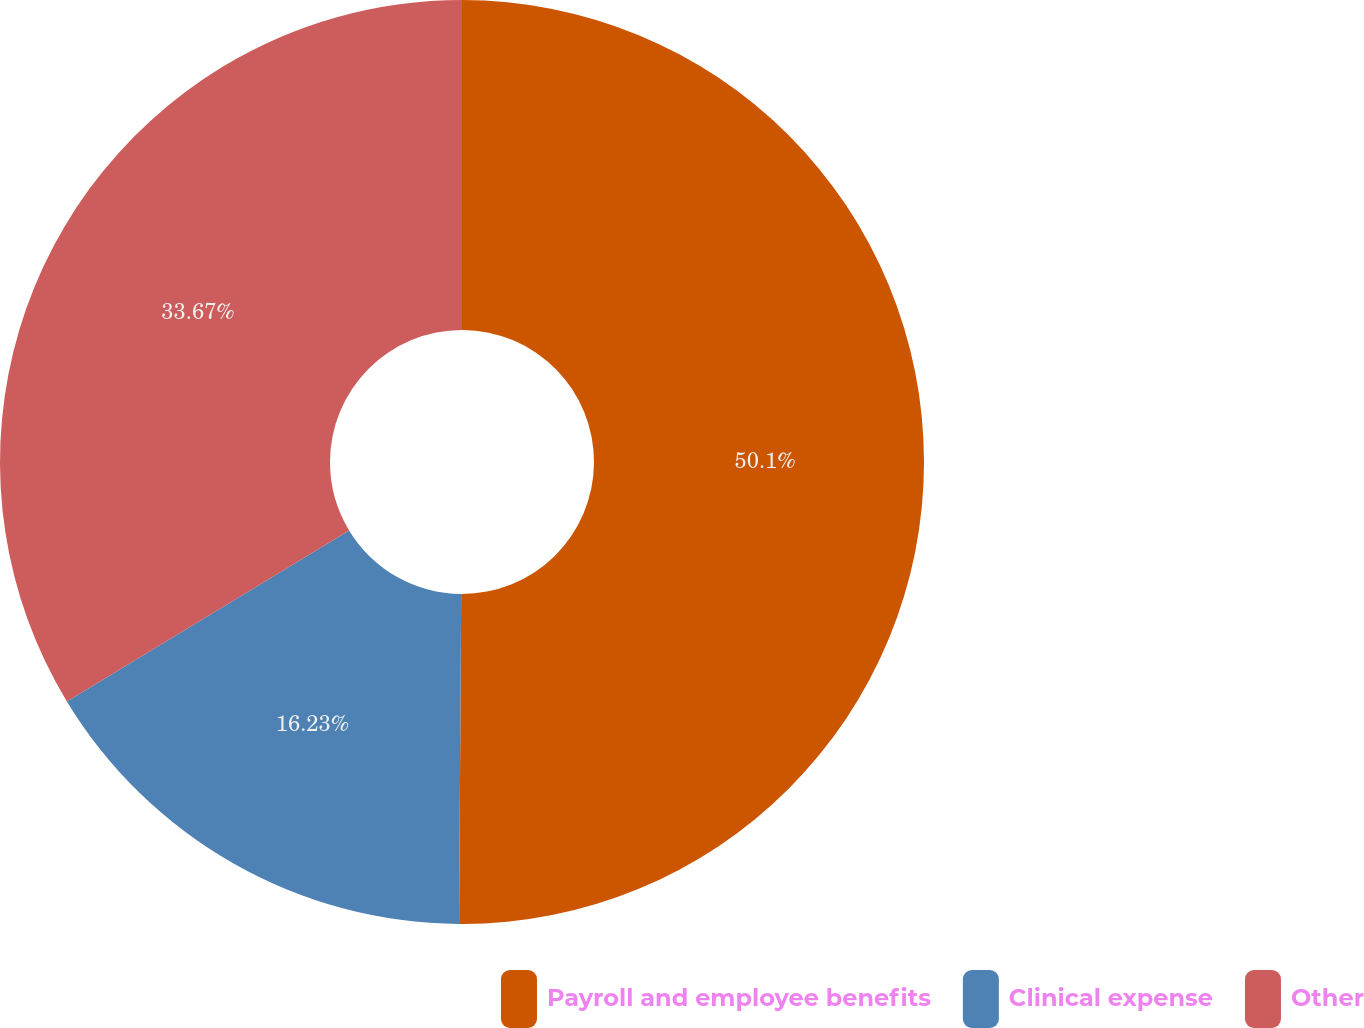<chart> <loc_0><loc_0><loc_500><loc_500><pie_chart><fcel>Payroll and employee benefits<fcel>Clinical expense<fcel>Other<nl><fcel>50.1%<fcel>16.23%<fcel>33.67%<nl></chart> 